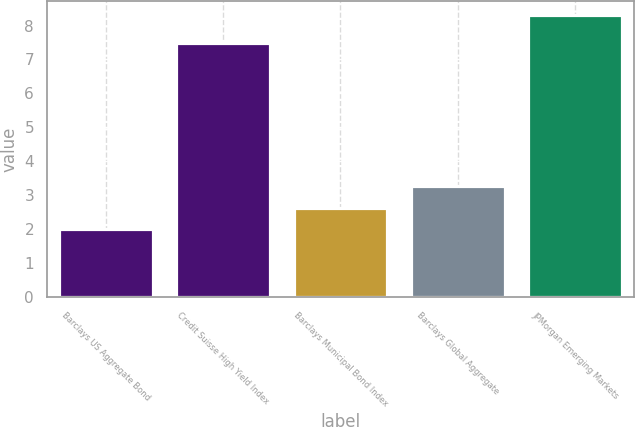Convert chart to OTSL. <chart><loc_0><loc_0><loc_500><loc_500><bar_chart><fcel>Barclays US Aggregate Bond<fcel>Credit Suisse High Yield Index<fcel>Barclays Municipal Bond Index<fcel>Barclays Global Aggregate<fcel>JPMorgan Emerging Markets<nl><fcel>2<fcel>7.5<fcel>2.63<fcel>3.26<fcel>8.3<nl></chart> 